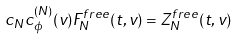<formula> <loc_0><loc_0><loc_500><loc_500>c _ { N } c ^ { ( N ) } _ { \phi } ( { v } ) F _ { N } ^ { f r e e } ( { t } , { v } ) = Z _ { N } ^ { f r e e } ( { t } , { v } )</formula> 